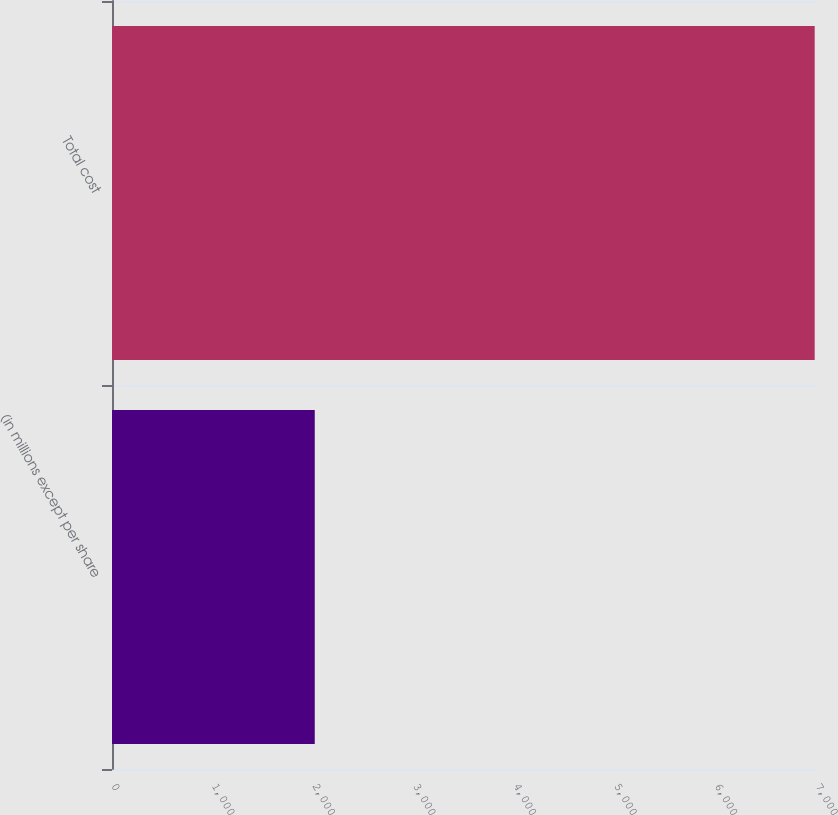<chart> <loc_0><loc_0><loc_500><loc_500><bar_chart><fcel>(in millions except per share<fcel>Total cost<nl><fcel>2016<fcel>6987<nl></chart> 